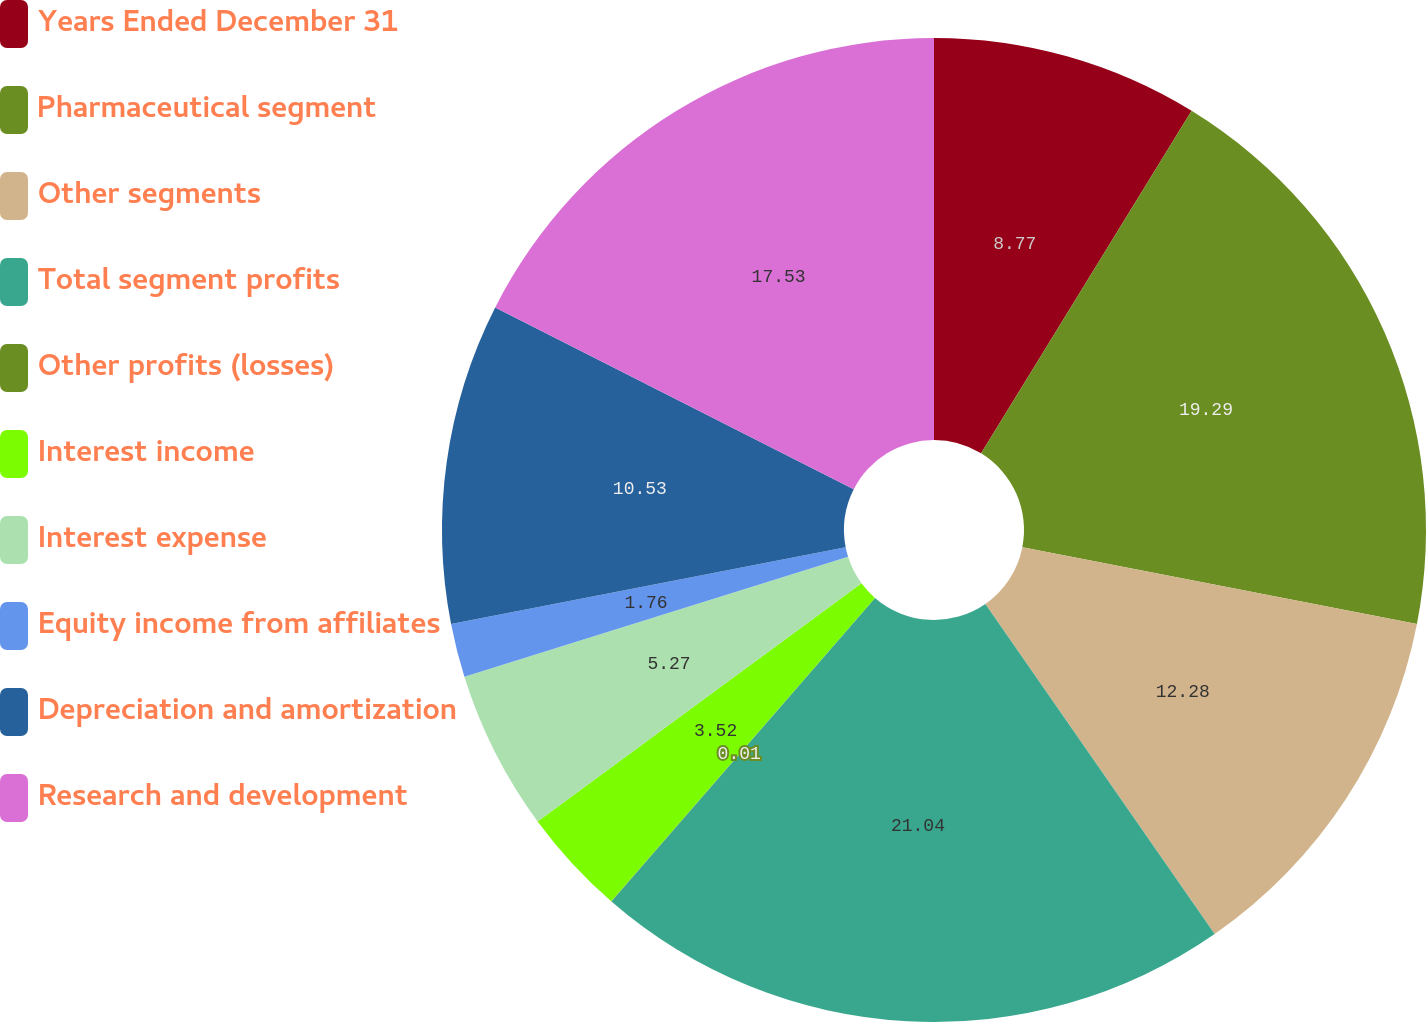Convert chart. <chart><loc_0><loc_0><loc_500><loc_500><pie_chart><fcel>Years Ended December 31<fcel>Pharmaceutical segment<fcel>Other segments<fcel>Total segment profits<fcel>Other profits (losses)<fcel>Interest income<fcel>Interest expense<fcel>Equity income from affiliates<fcel>Depreciation and amortization<fcel>Research and development<nl><fcel>8.77%<fcel>19.29%<fcel>12.28%<fcel>21.04%<fcel>0.01%<fcel>3.52%<fcel>5.27%<fcel>1.76%<fcel>10.53%<fcel>17.53%<nl></chart> 